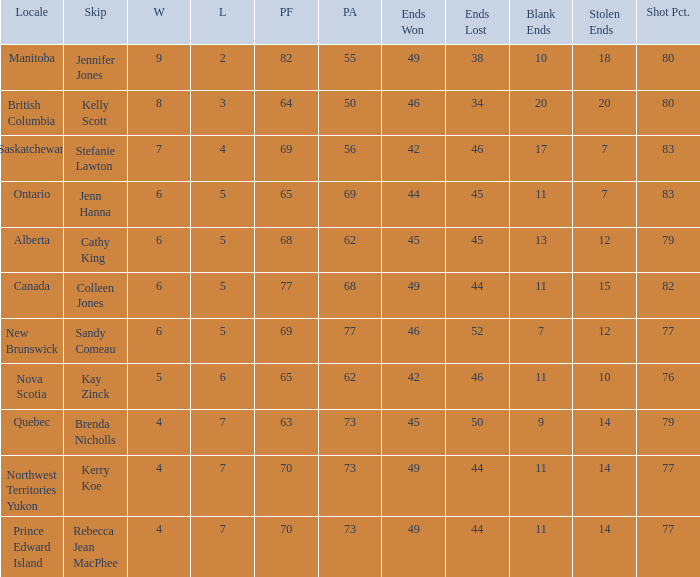What is the lowest power factor? 63.0. 